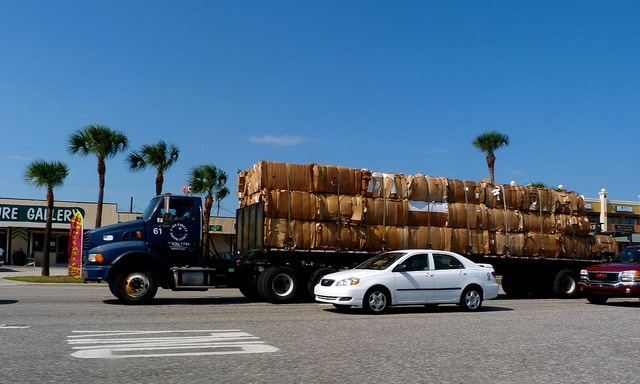Describe the objects in this image and their specific colors. I can see truck in gray, black, maroon, and olive tones, car in gray, black, lightgray, and darkgray tones, and car in gray, black, maroon, and navy tones in this image. 